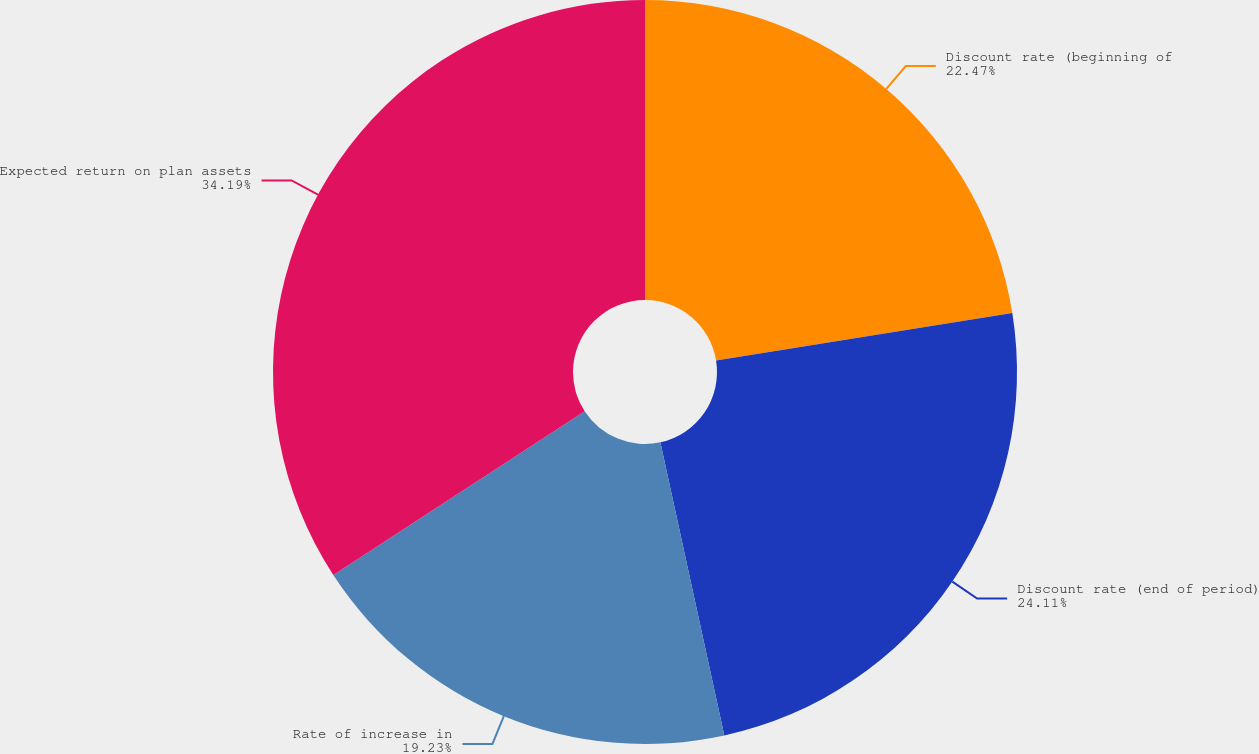Convert chart to OTSL. <chart><loc_0><loc_0><loc_500><loc_500><pie_chart><fcel>Discount rate (beginning of<fcel>Discount rate (end of period)<fcel>Rate of increase in<fcel>Expected return on plan assets<nl><fcel>22.47%<fcel>24.11%<fcel>19.23%<fcel>34.19%<nl></chart> 